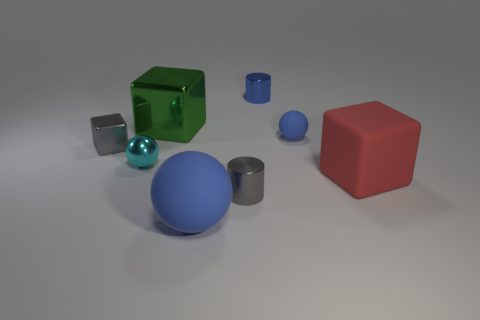How many blue balls must be subtracted to get 1 blue balls? 1 Add 1 tiny gray cubes. How many objects exist? 9 Subtract all cylinders. How many objects are left? 6 Add 8 cyan metal balls. How many cyan metal balls exist? 9 Subtract 0 red cylinders. How many objects are left? 8 Subtract all large green shiny blocks. Subtract all big blue metal spheres. How many objects are left? 7 Add 5 green metallic blocks. How many green metallic blocks are left? 6 